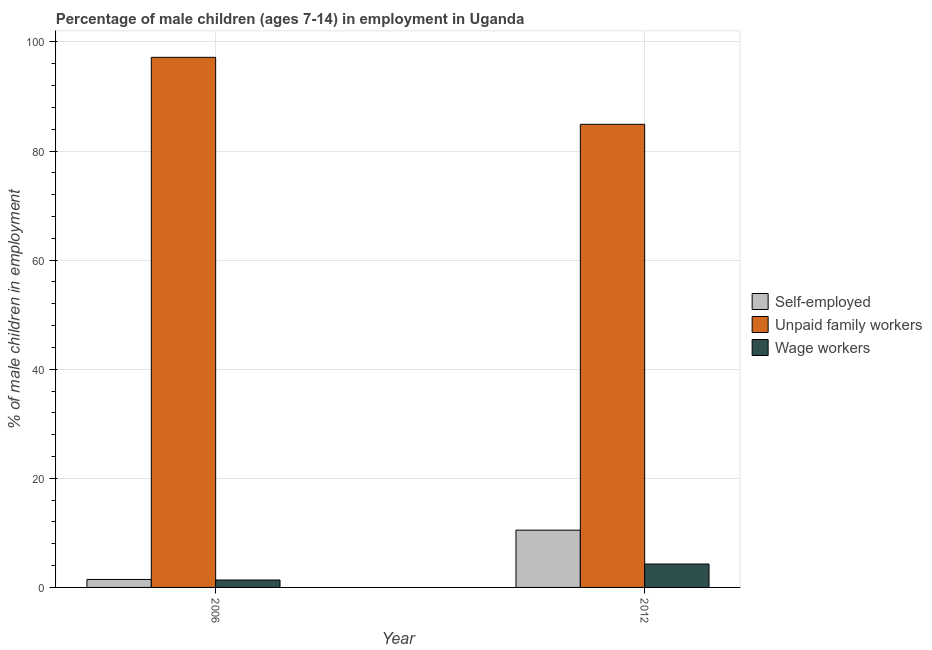How many bars are there on the 1st tick from the right?
Your answer should be compact. 3. What is the percentage of children employed as unpaid family workers in 2012?
Provide a short and direct response. 84.9. Across all years, what is the maximum percentage of children employed as unpaid family workers?
Provide a short and direct response. 97.18. Across all years, what is the minimum percentage of children employed as wage workers?
Make the answer very short. 1.36. In which year was the percentage of self employed children maximum?
Give a very brief answer. 2012. In which year was the percentage of self employed children minimum?
Ensure brevity in your answer.  2006. What is the total percentage of children employed as unpaid family workers in the graph?
Make the answer very short. 182.08. What is the difference between the percentage of children employed as unpaid family workers in 2006 and that in 2012?
Your answer should be compact. 12.28. What is the difference between the percentage of self employed children in 2006 and the percentage of children employed as unpaid family workers in 2012?
Offer a very short reply. -9.04. What is the average percentage of children employed as wage workers per year?
Provide a short and direct response. 2.83. In the year 2012, what is the difference between the percentage of children employed as wage workers and percentage of children employed as unpaid family workers?
Keep it short and to the point. 0. What is the ratio of the percentage of self employed children in 2006 to that in 2012?
Give a very brief answer. 0.14. Is the percentage of children employed as wage workers in 2006 less than that in 2012?
Your answer should be compact. Yes. What does the 2nd bar from the left in 2006 represents?
Provide a short and direct response. Unpaid family workers. What does the 1st bar from the right in 2006 represents?
Provide a succinct answer. Wage workers. What is the difference between two consecutive major ticks on the Y-axis?
Make the answer very short. 20. Are the values on the major ticks of Y-axis written in scientific E-notation?
Your answer should be compact. No. Does the graph contain grids?
Provide a short and direct response. Yes. Where does the legend appear in the graph?
Your answer should be very brief. Center right. How many legend labels are there?
Provide a short and direct response. 3. How are the legend labels stacked?
Keep it short and to the point. Vertical. What is the title of the graph?
Give a very brief answer. Percentage of male children (ages 7-14) in employment in Uganda. What is the label or title of the X-axis?
Offer a terse response. Year. What is the label or title of the Y-axis?
Provide a succinct answer. % of male children in employment. What is the % of male children in employment of Self-employed in 2006?
Provide a succinct answer. 1.46. What is the % of male children in employment in Unpaid family workers in 2006?
Offer a terse response. 97.18. What is the % of male children in employment of Wage workers in 2006?
Give a very brief answer. 1.36. What is the % of male children in employment of Self-employed in 2012?
Provide a succinct answer. 10.5. What is the % of male children in employment of Unpaid family workers in 2012?
Provide a succinct answer. 84.9. What is the % of male children in employment of Wage workers in 2012?
Provide a short and direct response. 4.29. Across all years, what is the maximum % of male children in employment of Unpaid family workers?
Your response must be concise. 97.18. Across all years, what is the maximum % of male children in employment in Wage workers?
Ensure brevity in your answer.  4.29. Across all years, what is the minimum % of male children in employment of Self-employed?
Ensure brevity in your answer.  1.46. Across all years, what is the minimum % of male children in employment of Unpaid family workers?
Keep it short and to the point. 84.9. Across all years, what is the minimum % of male children in employment of Wage workers?
Provide a short and direct response. 1.36. What is the total % of male children in employment in Self-employed in the graph?
Offer a very short reply. 11.96. What is the total % of male children in employment of Unpaid family workers in the graph?
Make the answer very short. 182.08. What is the total % of male children in employment in Wage workers in the graph?
Make the answer very short. 5.65. What is the difference between the % of male children in employment of Self-employed in 2006 and that in 2012?
Keep it short and to the point. -9.04. What is the difference between the % of male children in employment of Unpaid family workers in 2006 and that in 2012?
Give a very brief answer. 12.28. What is the difference between the % of male children in employment of Wage workers in 2006 and that in 2012?
Offer a very short reply. -2.93. What is the difference between the % of male children in employment of Self-employed in 2006 and the % of male children in employment of Unpaid family workers in 2012?
Offer a terse response. -83.44. What is the difference between the % of male children in employment of Self-employed in 2006 and the % of male children in employment of Wage workers in 2012?
Ensure brevity in your answer.  -2.83. What is the difference between the % of male children in employment of Unpaid family workers in 2006 and the % of male children in employment of Wage workers in 2012?
Your answer should be compact. 92.89. What is the average % of male children in employment of Self-employed per year?
Provide a short and direct response. 5.98. What is the average % of male children in employment in Unpaid family workers per year?
Your answer should be compact. 91.04. What is the average % of male children in employment of Wage workers per year?
Give a very brief answer. 2.83. In the year 2006, what is the difference between the % of male children in employment of Self-employed and % of male children in employment of Unpaid family workers?
Offer a terse response. -95.72. In the year 2006, what is the difference between the % of male children in employment in Self-employed and % of male children in employment in Wage workers?
Give a very brief answer. 0.1. In the year 2006, what is the difference between the % of male children in employment of Unpaid family workers and % of male children in employment of Wage workers?
Your answer should be compact. 95.82. In the year 2012, what is the difference between the % of male children in employment in Self-employed and % of male children in employment in Unpaid family workers?
Your answer should be compact. -74.4. In the year 2012, what is the difference between the % of male children in employment of Self-employed and % of male children in employment of Wage workers?
Ensure brevity in your answer.  6.21. In the year 2012, what is the difference between the % of male children in employment in Unpaid family workers and % of male children in employment in Wage workers?
Ensure brevity in your answer.  80.61. What is the ratio of the % of male children in employment in Self-employed in 2006 to that in 2012?
Provide a short and direct response. 0.14. What is the ratio of the % of male children in employment of Unpaid family workers in 2006 to that in 2012?
Offer a terse response. 1.14. What is the ratio of the % of male children in employment in Wage workers in 2006 to that in 2012?
Make the answer very short. 0.32. What is the difference between the highest and the second highest % of male children in employment in Self-employed?
Provide a succinct answer. 9.04. What is the difference between the highest and the second highest % of male children in employment in Unpaid family workers?
Provide a succinct answer. 12.28. What is the difference between the highest and the second highest % of male children in employment of Wage workers?
Your response must be concise. 2.93. What is the difference between the highest and the lowest % of male children in employment of Self-employed?
Provide a succinct answer. 9.04. What is the difference between the highest and the lowest % of male children in employment of Unpaid family workers?
Your response must be concise. 12.28. What is the difference between the highest and the lowest % of male children in employment of Wage workers?
Provide a short and direct response. 2.93. 